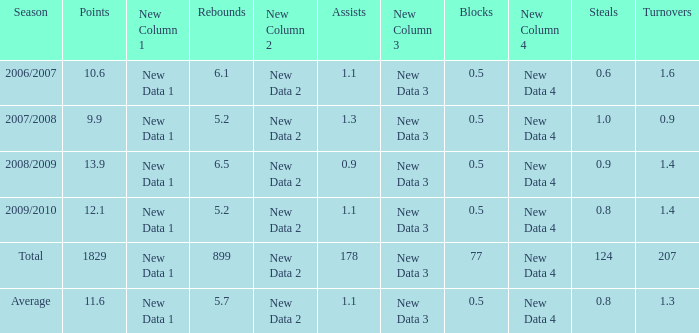How many blocks are there when the rebounds are fewer than 5.2? 0.0. 